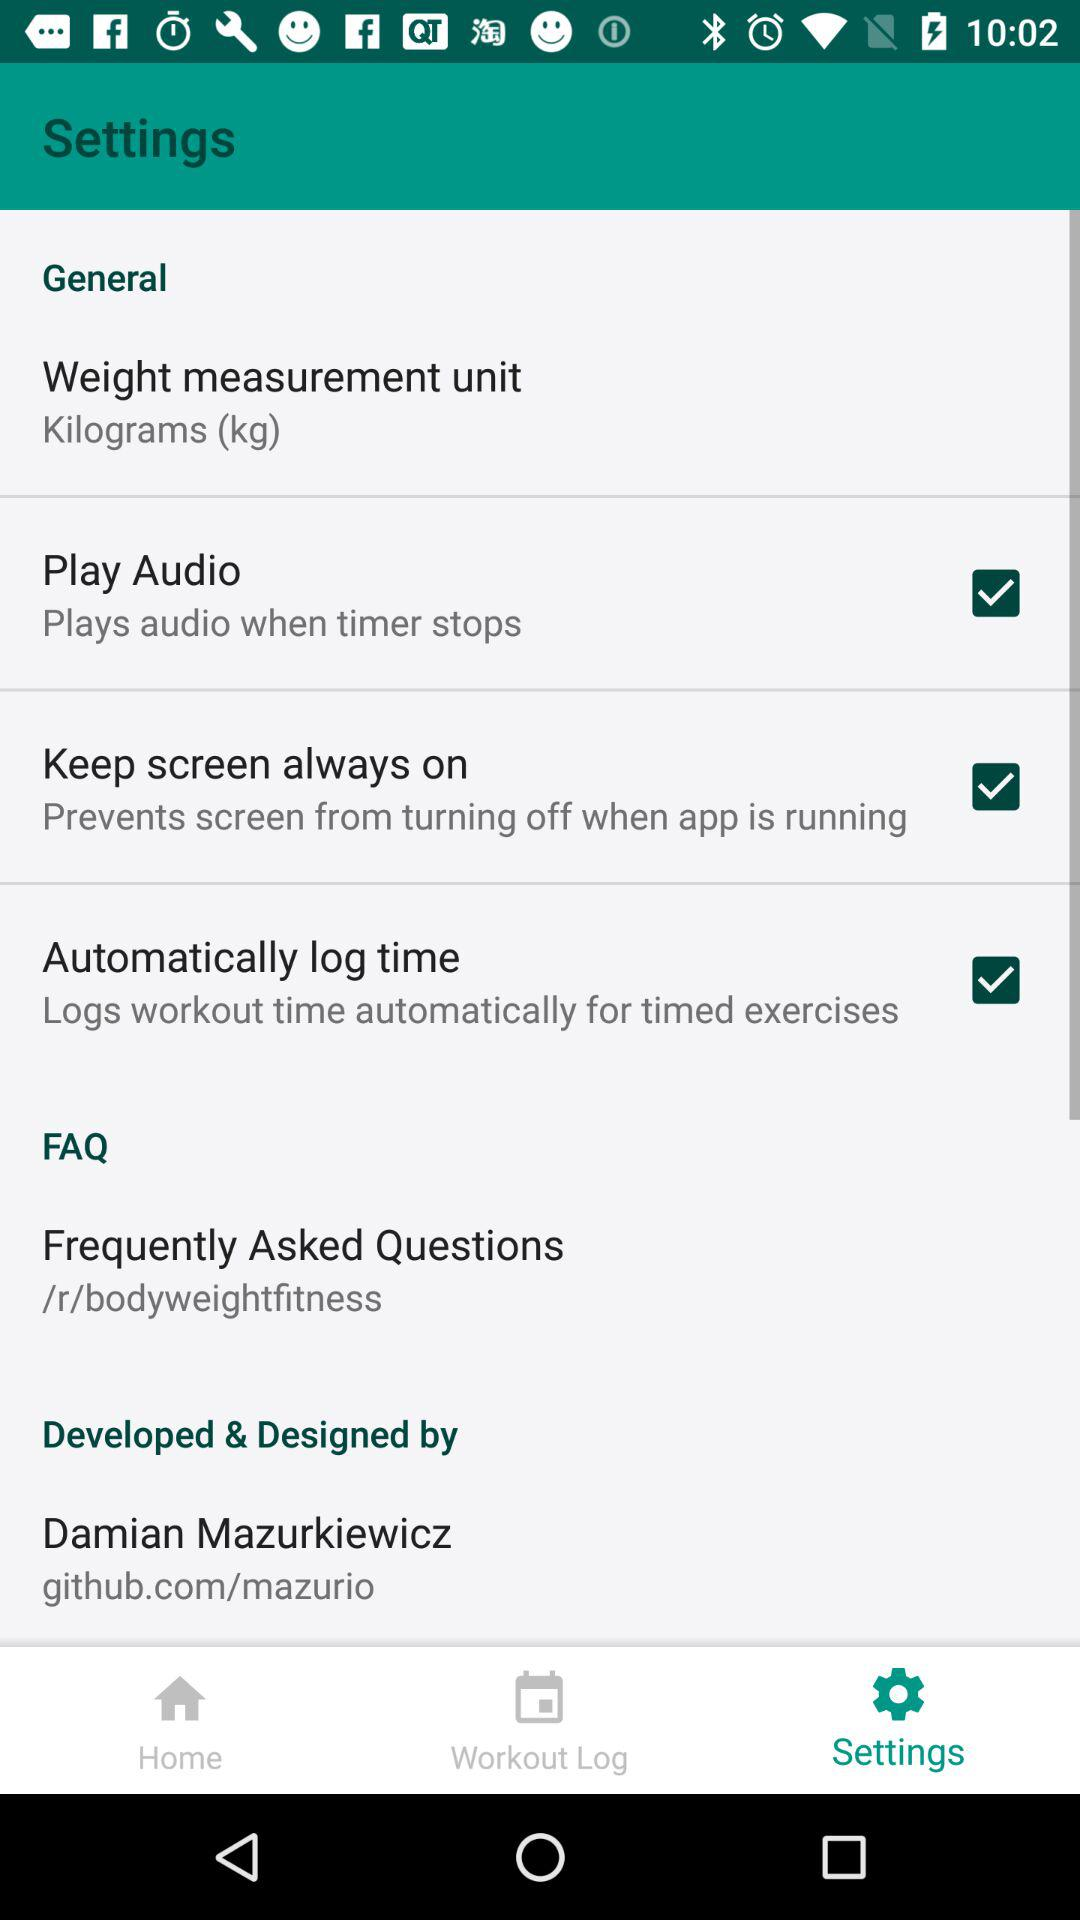How many of the items on the Settings screen have a checkbox?
Answer the question using a single word or phrase. 3 